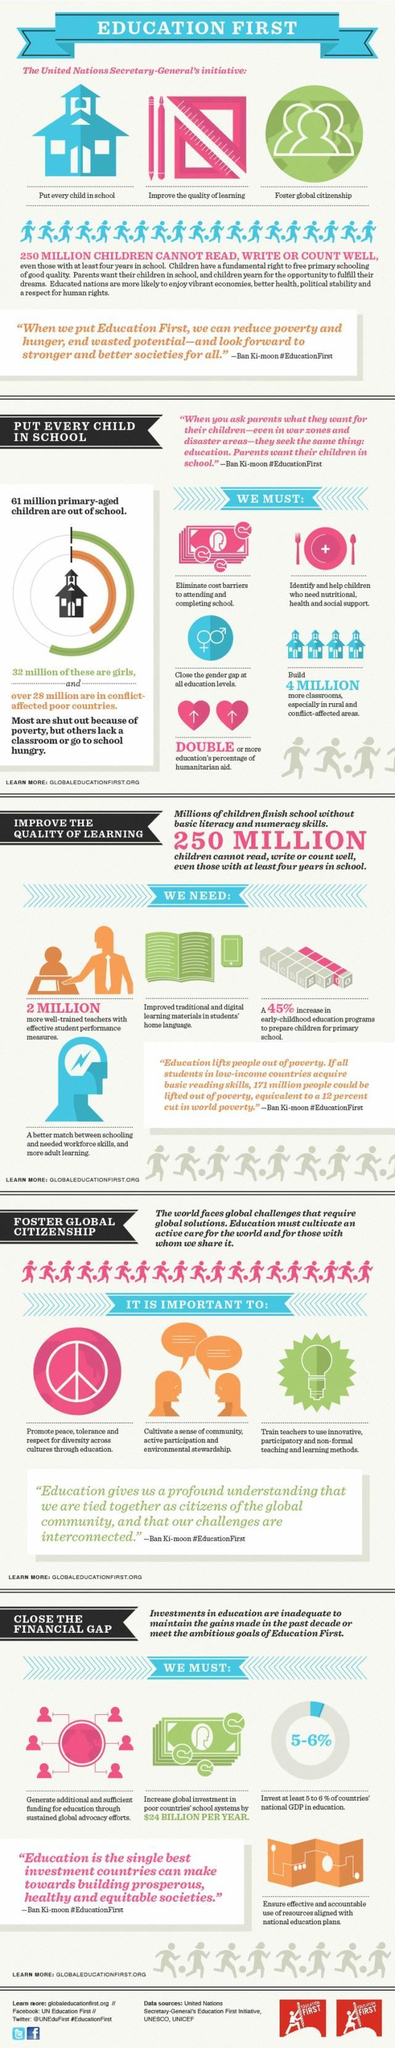what is the name of the UN Secretary General
Answer the question with a short phrase. Ban Ki-moon what is the need for sustained global advocacy efforts generate additional and sufficient funding for education what sign is shown on the plate + how many million primary-aged children who are out of school are boys 29 What are the initiatives of Ban ki-moon Put every child in school, Improve the quality of learning, Foster global citizenship how many more well-trained teachers are required 2 million 